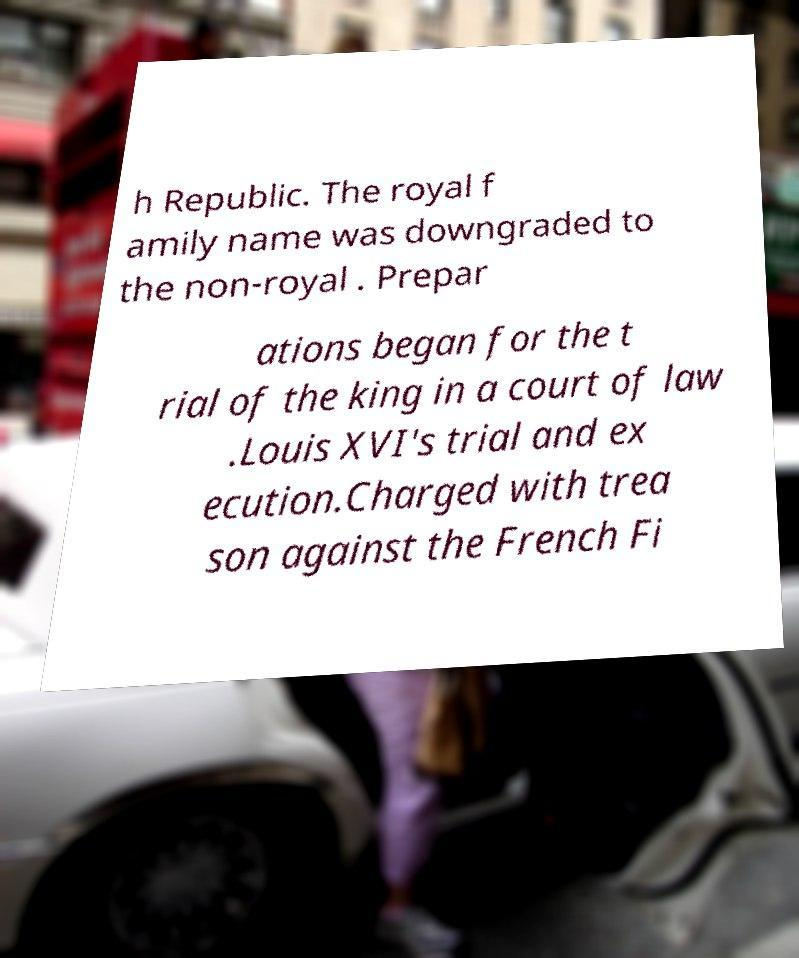Can you read and provide the text displayed in the image?This photo seems to have some interesting text. Can you extract and type it out for me? h Republic. The royal f amily name was downgraded to the non-royal . Prepar ations began for the t rial of the king in a court of law .Louis XVI's trial and ex ecution.Charged with trea son against the French Fi 